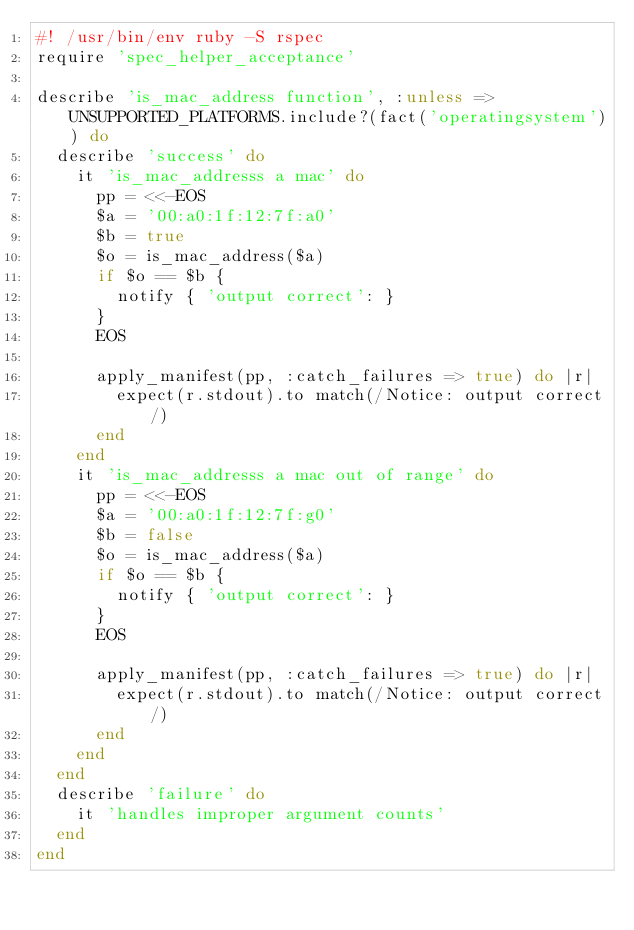<code> <loc_0><loc_0><loc_500><loc_500><_Ruby_>#! /usr/bin/env ruby -S rspec
require 'spec_helper_acceptance'

describe 'is_mac_address function', :unless => UNSUPPORTED_PLATFORMS.include?(fact('operatingsystem')) do
  describe 'success' do
    it 'is_mac_addresss a mac' do
      pp = <<-EOS
      $a = '00:a0:1f:12:7f:a0'
      $b = true
      $o = is_mac_address($a)
      if $o == $b {
        notify { 'output correct': }
      }
      EOS

      apply_manifest(pp, :catch_failures => true) do |r|
        expect(r.stdout).to match(/Notice: output correct/)
      end
    end
    it 'is_mac_addresss a mac out of range' do
      pp = <<-EOS
      $a = '00:a0:1f:12:7f:g0'
      $b = false
      $o = is_mac_address($a)
      if $o == $b {
        notify { 'output correct': }
      }
      EOS

      apply_manifest(pp, :catch_failures => true) do |r|
        expect(r.stdout).to match(/Notice: output correct/)
      end
    end
  end
  describe 'failure' do
    it 'handles improper argument counts'
  end
end
</code> 